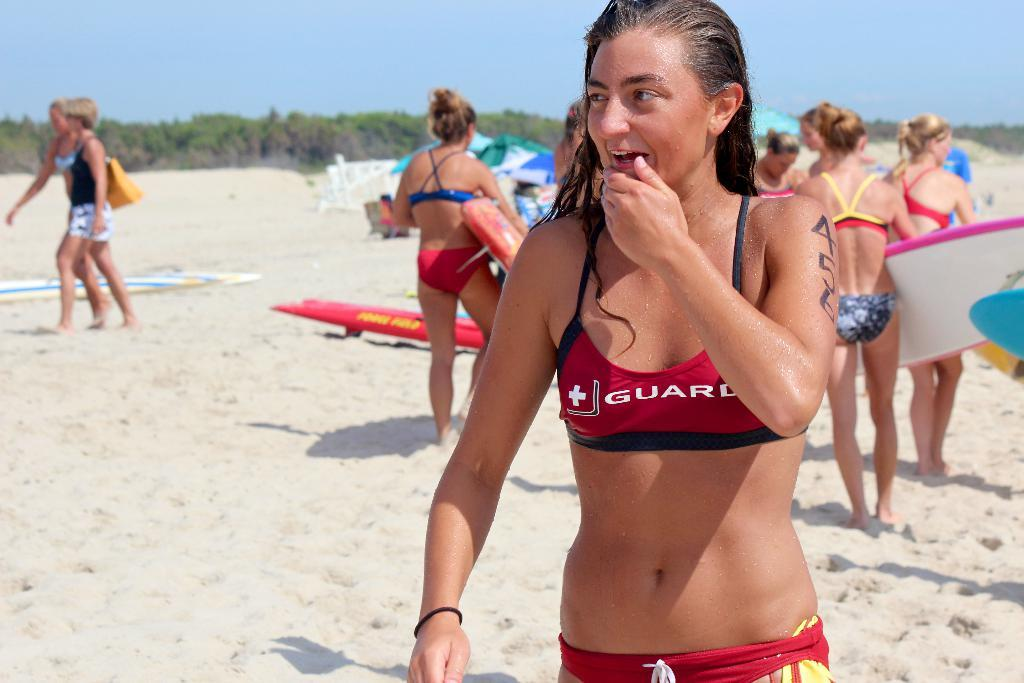<image>
Create a compact narrative representing the image presented. A woman on a beack wears a red swim top with a white cross and the word Guard on it as she stands on a beach. 